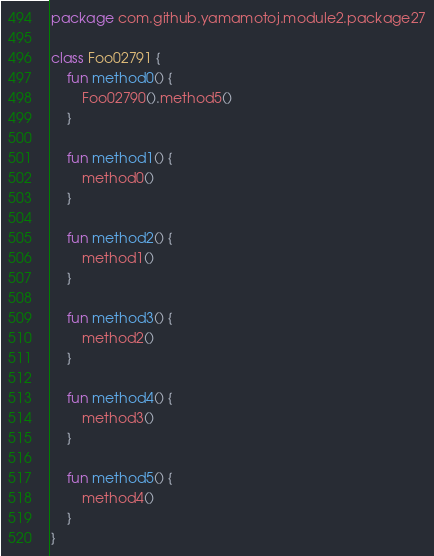Convert code to text. <code><loc_0><loc_0><loc_500><loc_500><_Kotlin_>package com.github.yamamotoj.module2.package27

class Foo02791 {
    fun method0() {
        Foo02790().method5()
    }

    fun method1() {
        method0()
    }

    fun method2() {
        method1()
    }

    fun method3() {
        method2()
    }

    fun method4() {
        method3()
    }

    fun method5() {
        method4()
    }
}
</code> 